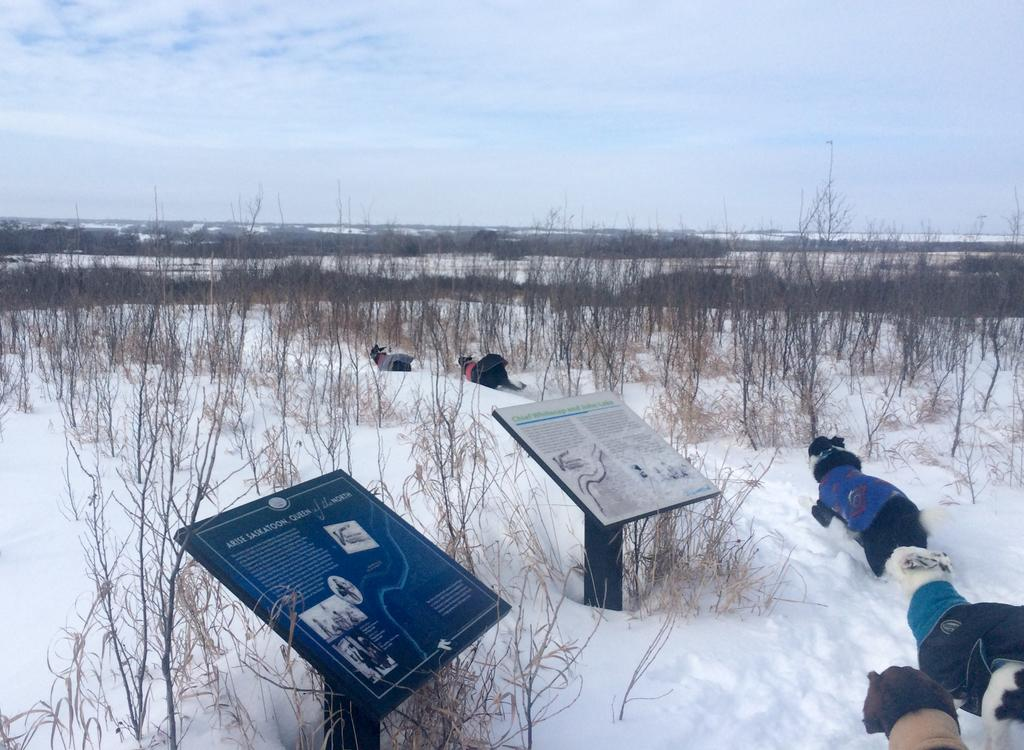What is happening in the foreground of the image? There are animals in the snow in the foreground of the image. What can be seen in the image that might help with navigation? There are direction indicator boards in the image. What type of natural environment is visible in the image? There are trees in the image. What is visible in the sky in the image? There are clouds in the sky. What type of breakfast is being served in the image? There is no breakfast present in the image. Can you describe the curve of the animals in the image? The animals in the image are not depicted as having a curve. 